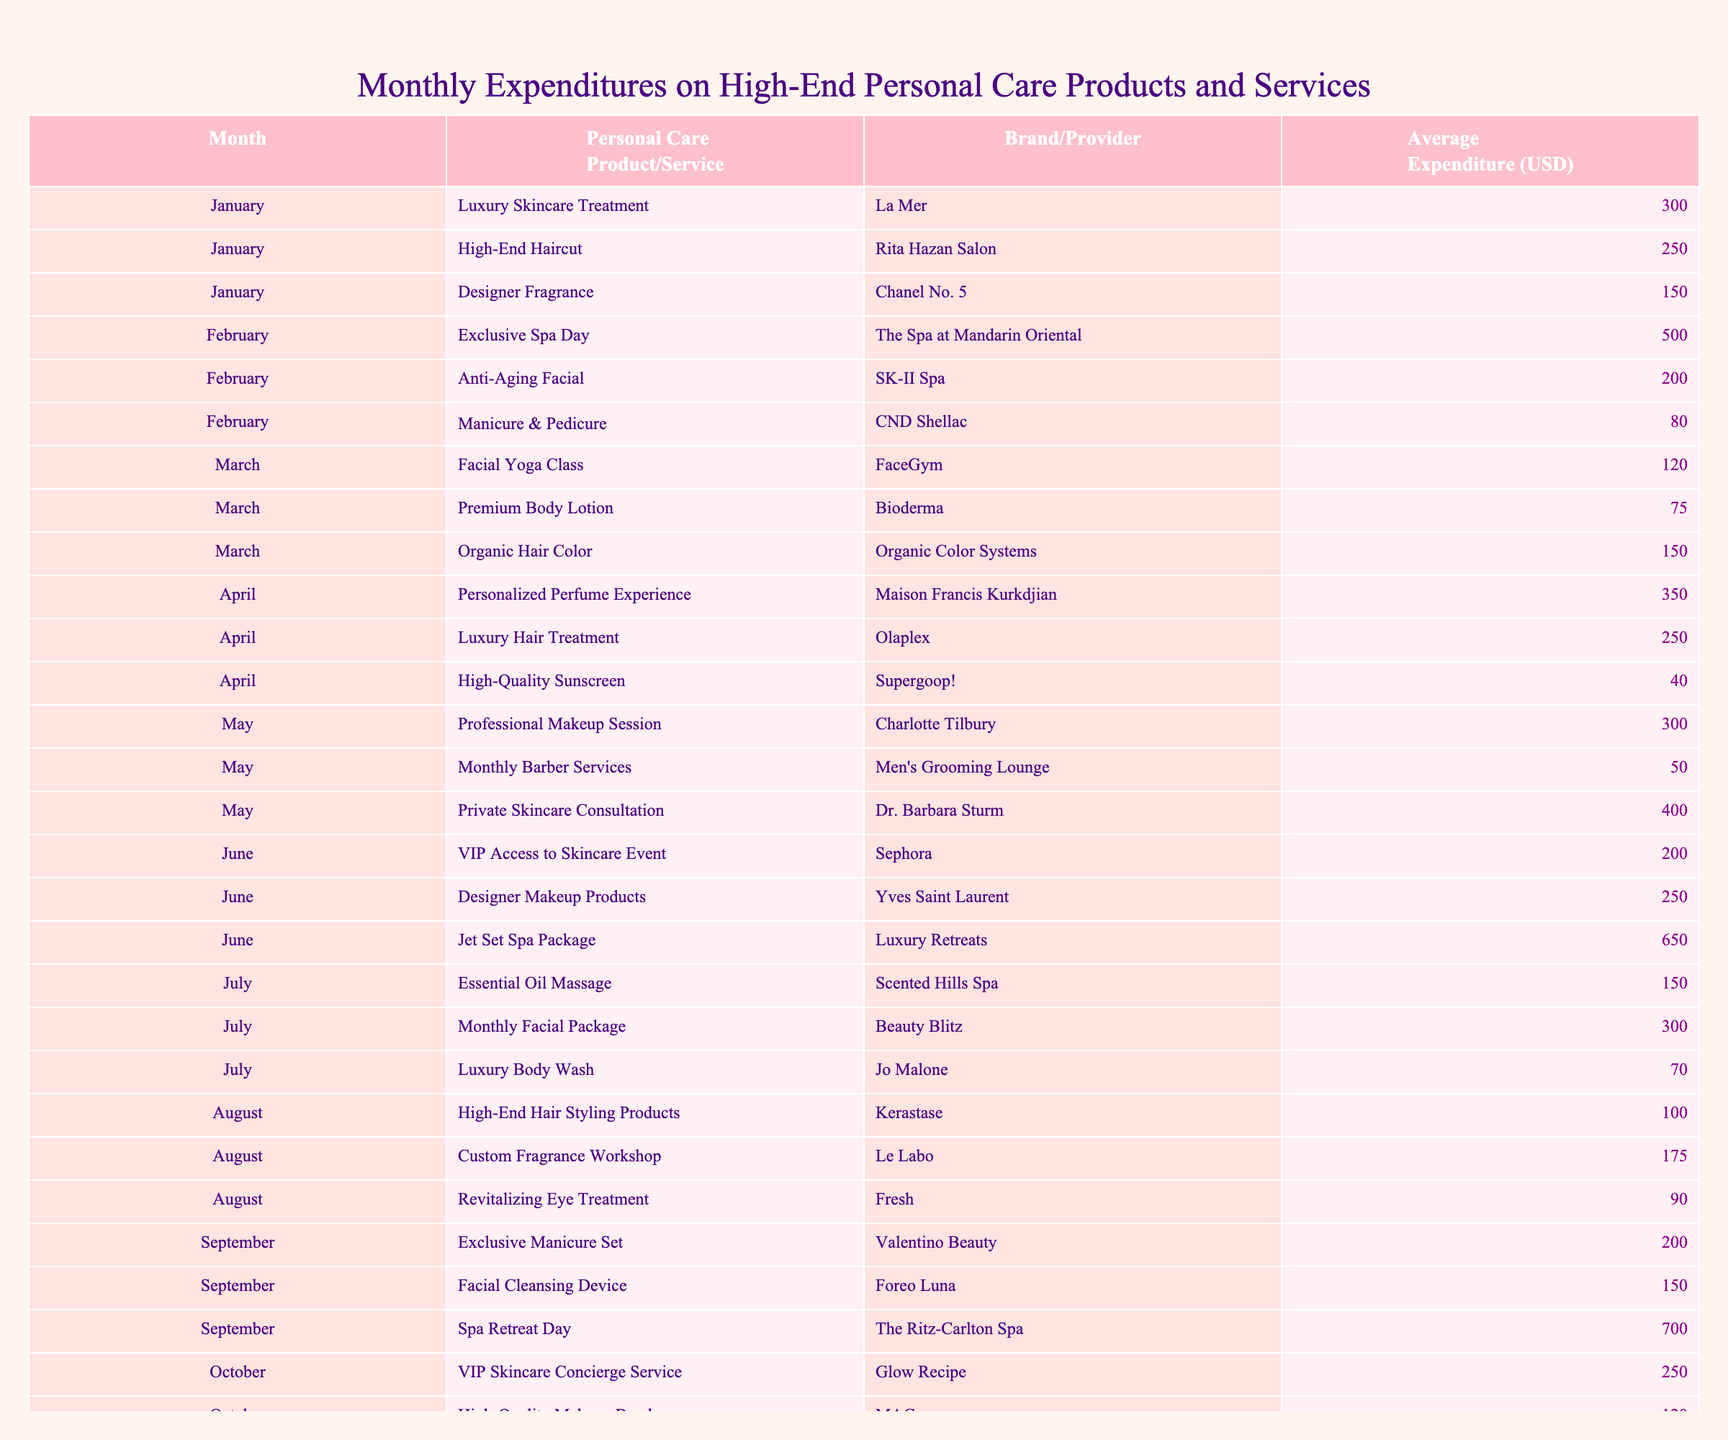What is the total average expenditure for March? The average expenditures in March are: Facial Yoga Class (120), Premium Body Lotion (75), and Organic Hair Color (150). To find the total, we sum these amounts: 120 + 75 + 150 = 345.
Answer: 345 Which month had the highest expenditure on a single service or product? By reviewing the expenditures, we find the following highest amounts: Exclusive Spa Day (500 in February) and Spa Retreat Day (700 in September). The highest expenditure is 700 in September for Spa Retreat Day.
Answer: September How much was spent on skincare services in total from January to March? The skincare services in these months are: Luxury Skincare Treatment (300 in January), Anti-Aging Facial (200 in February), and Monthly Facial Package (300 in July, but it's outside the range). Adding these, we have: 300 + 200 = 500.
Answer: 500 Did any month have less than 100 USD spent on personal care services? Upon checking the expenditures in all months, we see that in April the High-Quality Sunscreen was only 40. So, yes, there was a month with an expenditure less than 100 USD.
Answer: Yes What is the average expenditure for hair services across all months? The hair services are as follows: High-End Haircut (250 in January), Organic Hair Color (150 in March), Luxury Hair Treatment (250 in April), Monthly Barber Services (50 in May), and Luxury Body Wash (70 in July). Adding these gives us: 250 + 150 + 250 + 50 + 70 = 770. Since there are 5 items, the average is 770 / 5 = 154.
Answer: 154 